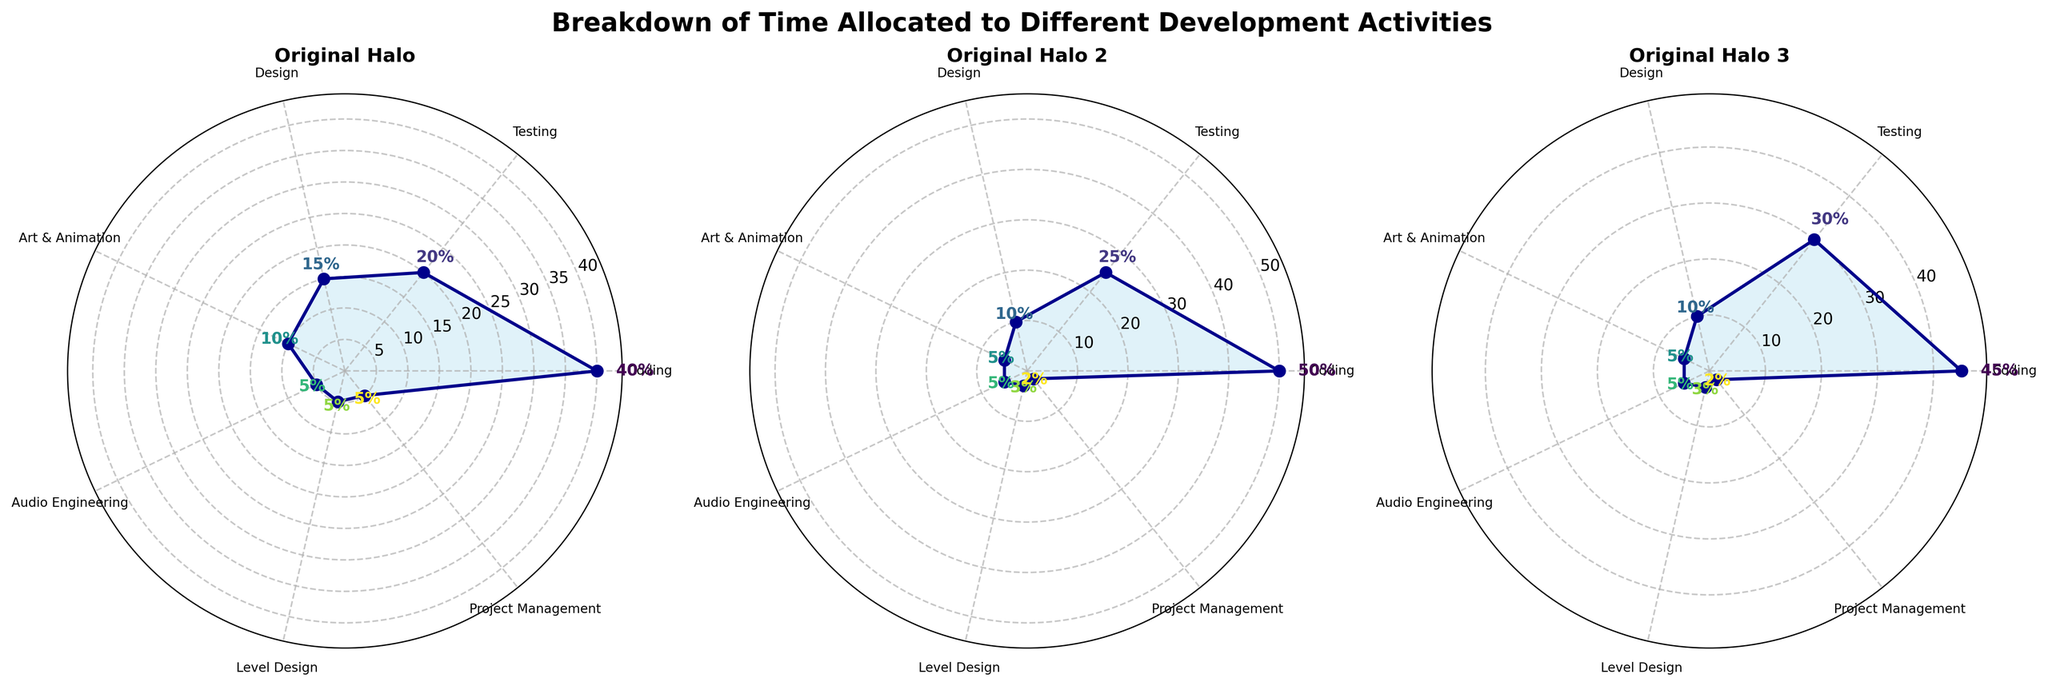What's the title of the figure? The title of the figure is usually placed at the top center. According to the description, the title is "Breakdown of Time Allocated to Different Development Activities".
Answer: Breakdown of Time Allocated to Different Development Activities How many development activities are shown in each subplot? Each subplot consists of labels around the rose chart. By counting these labels, we can determine the number of activities. Each subplot has seven activities: Coding, Testing, Design, Art & Animation, Audio Engineering, Level Design, and Project Management.
Answer: 7 Which activity had the highest time allocation in Original Halo 2? By inspecting the Original Halo 2 subplot, the activity with the longest radial line corresponds to the highest percentage value. Coding has the highest allocation at 50%.
Answer: Coding What's the total percentage of time allocated to Coding over all three games? Sum the time allocated for Coding from each of the three subplots: Original Halo (40%), Original Halo 2 (50%), and Original Halo 3 (45%). So, the total is 40 + 50 + 45 = 135%.
Answer: 135% Which activity showed the most significant increase from Original Halo to Original Halo 3? Compare the percentages of each activity between Original Halo and Original Halo 3. Testing increased from 20% in Original Halo to 30% in Original Halo 3, which is the highest increase of 10%.
Answer: Testing What is the average percentage allocation for Design across all three games? Calculate the average percentage for Design across Original Halo (15%), Original Halo 2 (10%), and Original Halo 3 (10%). The average is (15 + 10 + 10) / 3 = 11.67%.
Answer: 11.67% Which activity remained constant across all three games? Look for an activity with the same value in all three subplots. Audio Engineering had a constant allocation of 5% in all three games.
Answer: Audio Engineering What is the difference in the percentage allocation for Art & Animation between Original Halo and Original Halo 3? The percentage allocation for Art & Animation is 10% in Original Halo and 5% in Original Halo 3. The difference is 10 - 5 = 5%.
Answer: 5% Is the time spent on Project Management higher or lower in Original Halo than in Original Halo 3? Compare the time allocation percentages for Project Management in Original Halo (5%) and Original Halo 3 (2%). It is higher in Original Halo.
Answer: Higher Which game dedicated the least percentage of time to Level Design? By checking the percentages allocated to Level Design in each game, we see that Original Halo 2 and Original Halo 3 both spent 3%, which is less than Original Halo's 5%. Both Original Halo 2 and Original Halo 3 dedicated the least time to Level Design compared to the other games.
Answer: Original Halo 2 and Original Halo 3 